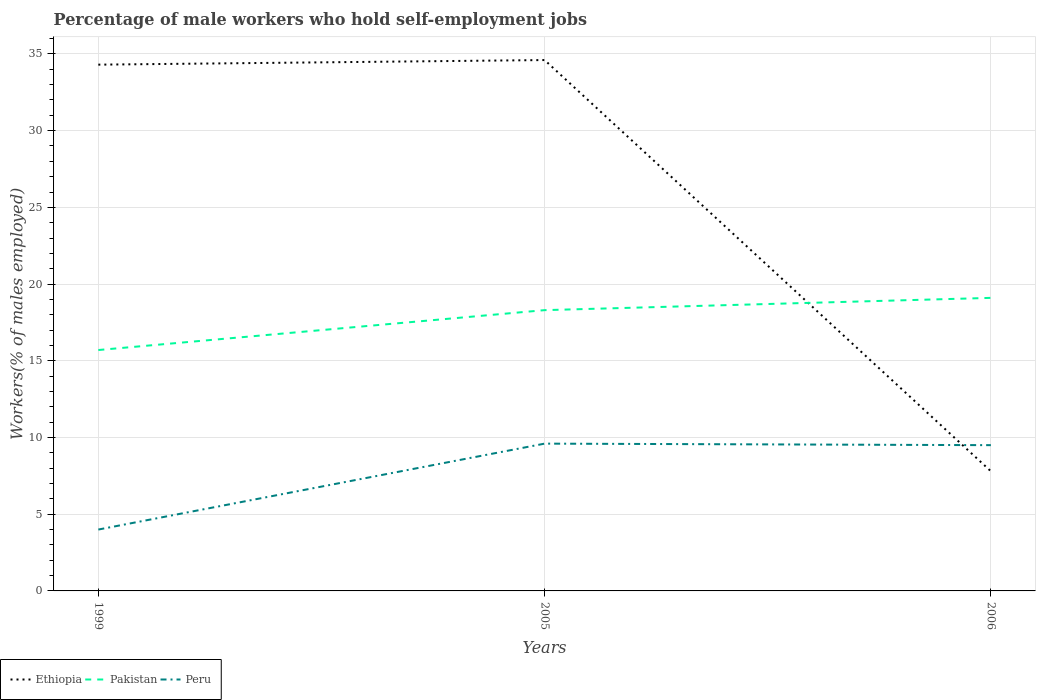Does the line corresponding to Ethiopia intersect with the line corresponding to Peru?
Ensure brevity in your answer.  Yes. What is the total percentage of self-employed male workers in Pakistan in the graph?
Your response must be concise. -2.6. What is the difference between the highest and the second highest percentage of self-employed male workers in Ethiopia?
Offer a very short reply. 26.8. What is the difference between the highest and the lowest percentage of self-employed male workers in Peru?
Make the answer very short. 2. Is the percentage of self-employed male workers in Peru strictly greater than the percentage of self-employed male workers in Pakistan over the years?
Make the answer very short. Yes. What is the difference between two consecutive major ticks on the Y-axis?
Keep it short and to the point. 5. Does the graph contain grids?
Offer a terse response. Yes. Where does the legend appear in the graph?
Provide a succinct answer. Bottom left. What is the title of the graph?
Your answer should be compact. Percentage of male workers who hold self-employment jobs. Does "Mauritania" appear as one of the legend labels in the graph?
Your answer should be compact. No. What is the label or title of the X-axis?
Make the answer very short. Years. What is the label or title of the Y-axis?
Provide a succinct answer. Workers(% of males employed). What is the Workers(% of males employed) of Ethiopia in 1999?
Your answer should be compact. 34.3. What is the Workers(% of males employed) of Pakistan in 1999?
Give a very brief answer. 15.7. What is the Workers(% of males employed) in Ethiopia in 2005?
Keep it short and to the point. 34.6. What is the Workers(% of males employed) in Pakistan in 2005?
Your answer should be compact. 18.3. What is the Workers(% of males employed) of Peru in 2005?
Your response must be concise. 9.6. What is the Workers(% of males employed) in Ethiopia in 2006?
Make the answer very short. 7.8. What is the Workers(% of males employed) of Pakistan in 2006?
Your answer should be compact. 19.1. Across all years, what is the maximum Workers(% of males employed) of Ethiopia?
Your response must be concise. 34.6. Across all years, what is the maximum Workers(% of males employed) of Pakistan?
Offer a terse response. 19.1. Across all years, what is the maximum Workers(% of males employed) in Peru?
Offer a terse response. 9.6. Across all years, what is the minimum Workers(% of males employed) of Ethiopia?
Give a very brief answer. 7.8. Across all years, what is the minimum Workers(% of males employed) in Pakistan?
Provide a succinct answer. 15.7. What is the total Workers(% of males employed) in Ethiopia in the graph?
Give a very brief answer. 76.7. What is the total Workers(% of males employed) of Pakistan in the graph?
Give a very brief answer. 53.1. What is the total Workers(% of males employed) of Peru in the graph?
Make the answer very short. 23.1. What is the difference between the Workers(% of males employed) in Ethiopia in 1999 and that in 2005?
Offer a very short reply. -0.3. What is the difference between the Workers(% of males employed) in Pakistan in 1999 and that in 2005?
Offer a terse response. -2.6. What is the difference between the Workers(% of males employed) in Peru in 1999 and that in 2005?
Offer a very short reply. -5.6. What is the difference between the Workers(% of males employed) in Pakistan in 1999 and that in 2006?
Give a very brief answer. -3.4. What is the difference between the Workers(% of males employed) of Peru in 1999 and that in 2006?
Your response must be concise. -5.5. What is the difference between the Workers(% of males employed) of Ethiopia in 2005 and that in 2006?
Offer a terse response. 26.8. What is the difference between the Workers(% of males employed) of Pakistan in 2005 and that in 2006?
Your response must be concise. -0.8. What is the difference between the Workers(% of males employed) of Ethiopia in 1999 and the Workers(% of males employed) of Pakistan in 2005?
Provide a short and direct response. 16. What is the difference between the Workers(% of males employed) of Ethiopia in 1999 and the Workers(% of males employed) of Peru in 2005?
Provide a short and direct response. 24.7. What is the difference between the Workers(% of males employed) in Ethiopia in 1999 and the Workers(% of males employed) in Peru in 2006?
Your answer should be very brief. 24.8. What is the difference between the Workers(% of males employed) of Pakistan in 1999 and the Workers(% of males employed) of Peru in 2006?
Provide a succinct answer. 6.2. What is the difference between the Workers(% of males employed) of Ethiopia in 2005 and the Workers(% of males employed) of Pakistan in 2006?
Provide a succinct answer. 15.5. What is the difference between the Workers(% of males employed) in Ethiopia in 2005 and the Workers(% of males employed) in Peru in 2006?
Make the answer very short. 25.1. What is the difference between the Workers(% of males employed) of Pakistan in 2005 and the Workers(% of males employed) of Peru in 2006?
Keep it short and to the point. 8.8. What is the average Workers(% of males employed) of Ethiopia per year?
Your answer should be compact. 25.57. What is the average Workers(% of males employed) of Pakistan per year?
Offer a very short reply. 17.7. What is the average Workers(% of males employed) in Peru per year?
Give a very brief answer. 7.7. In the year 1999, what is the difference between the Workers(% of males employed) in Ethiopia and Workers(% of males employed) in Peru?
Offer a very short reply. 30.3. In the year 1999, what is the difference between the Workers(% of males employed) in Pakistan and Workers(% of males employed) in Peru?
Provide a short and direct response. 11.7. In the year 2005, what is the difference between the Workers(% of males employed) of Ethiopia and Workers(% of males employed) of Peru?
Offer a terse response. 25. In the year 2005, what is the difference between the Workers(% of males employed) of Pakistan and Workers(% of males employed) of Peru?
Provide a short and direct response. 8.7. In the year 2006, what is the difference between the Workers(% of males employed) in Ethiopia and Workers(% of males employed) in Peru?
Keep it short and to the point. -1.7. In the year 2006, what is the difference between the Workers(% of males employed) in Pakistan and Workers(% of males employed) in Peru?
Your answer should be compact. 9.6. What is the ratio of the Workers(% of males employed) of Pakistan in 1999 to that in 2005?
Your answer should be compact. 0.86. What is the ratio of the Workers(% of males employed) in Peru in 1999 to that in 2005?
Provide a succinct answer. 0.42. What is the ratio of the Workers(% of males employed) of Ethiopia in 1999 to that in 2006?
Your answer should be compact. 4.4. What is the ratio of the Workers(% of males employed) of Pakistan in 1999 to that in 2006?
Ensure brevity in your answer.  0.82. What is the ratio of the Workers(% of males employed) of Peru in 1999 to that in 2006?
Keep it short and to the point. 0.42. What is the ratio of the Workers(% of males employed) of Ethiopia in 2005 to that in 2006?
Your response must be concise. 4.44. What is the ratio of the Workers(% of males employed) in Pakistan in 2005 to that in 2006?
Give a very brief answer. 0.96. What is the ratio of the Workers(% of males employed) in Peru in 2005 to that in 2006?
Offer a very short reply. 1.01. What is the difference between the highest and the second highest Workers(% of males employed) in Pakistan?
Provide a succinct answer. 0.8. What is the difference between the highest and the second highest Workers(% of males employed) in Peru?
Provide a short and direct response. 0.1. What is the difference between the highest and the lowest Workers(% of males employed) of Ethiopia?
Offer a very short reply. 26.8. What is the difference between the highest and the lowest Workers(% of males employed) in Pakistan?
Provide a short and direct response. 3.4. 